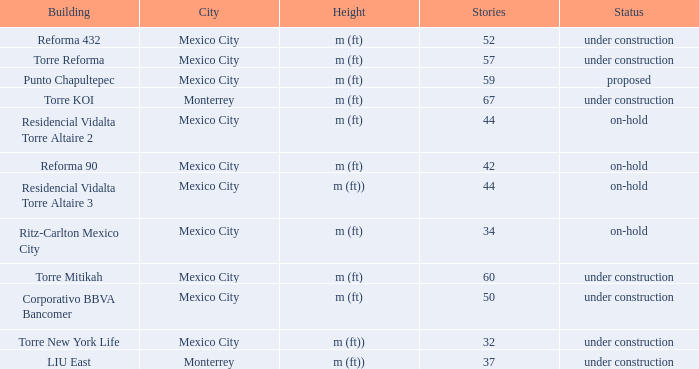Could you help me parse every detail presented in this table? {'header': ['Building', 'City', 'Height', 'Stories', 'Status'], 'rows': [['Reforma 432', 'Mexico City', 'm (ft)', '52', 'under construction'], ['Torre Reforma', 'Mexico City', 'm (ft)', '57', 'under construction'], ['Punto Chapultepec', 'Mexico City', 'm (ft)', '59', 'proposed'], ['Torre KOI', 'Monterrey', 'm (ft)', '67', 'under construction'], ['Residencial Vidalta Torre Altaire 2', 'Mexico City', 'm (ft)', '44', 'on-hold'], ['Reforma 90', 'Mexico City', 'm (ft)', '42', 'on-hold'], ['Residencial Vidalta Torre Altaire 3', 'Mexico City', 'm (ft))', '44', 'on-hold'], ['Ritz-Carlton Mexico City', 'Mexico City', 'm (ft)', '34', 'on-hold'], ['Torre Mitikah', 'Mexico City', 'm (ft)', '60', 'under construction'], ['Corporativo BBVA Bancomer', 'Mexico City', 'm (ft)', '50', 'under construction'], ['Torre New York Life', 'Mexico City', 'm (ft))', '32', 'under construction'], ['LIU East', 'Monterrey', 'm (ft))', '37', 'under construction']]} How tall is the 52 story building? M (ft). 